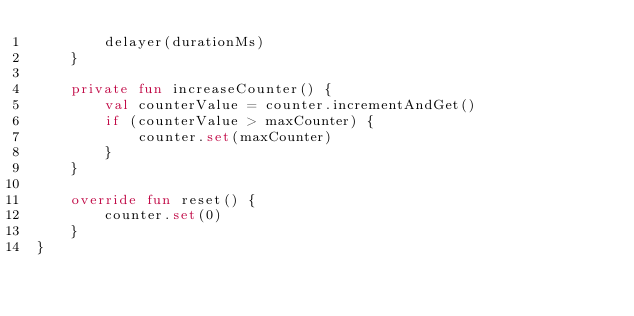<code> <loc_0><loc_0><loc_500><loc_500><_Kotlin_>        delayer(durationMs)
    }

    private fun increaseCounter() {
        val counterValue = counter.incrementAndGet()
        if (counterValue > maxCounter) {
            counter.set(maxCounter)
        }
    }

    override fun reset() {
        counter.set(0)
    }
}
</code> 